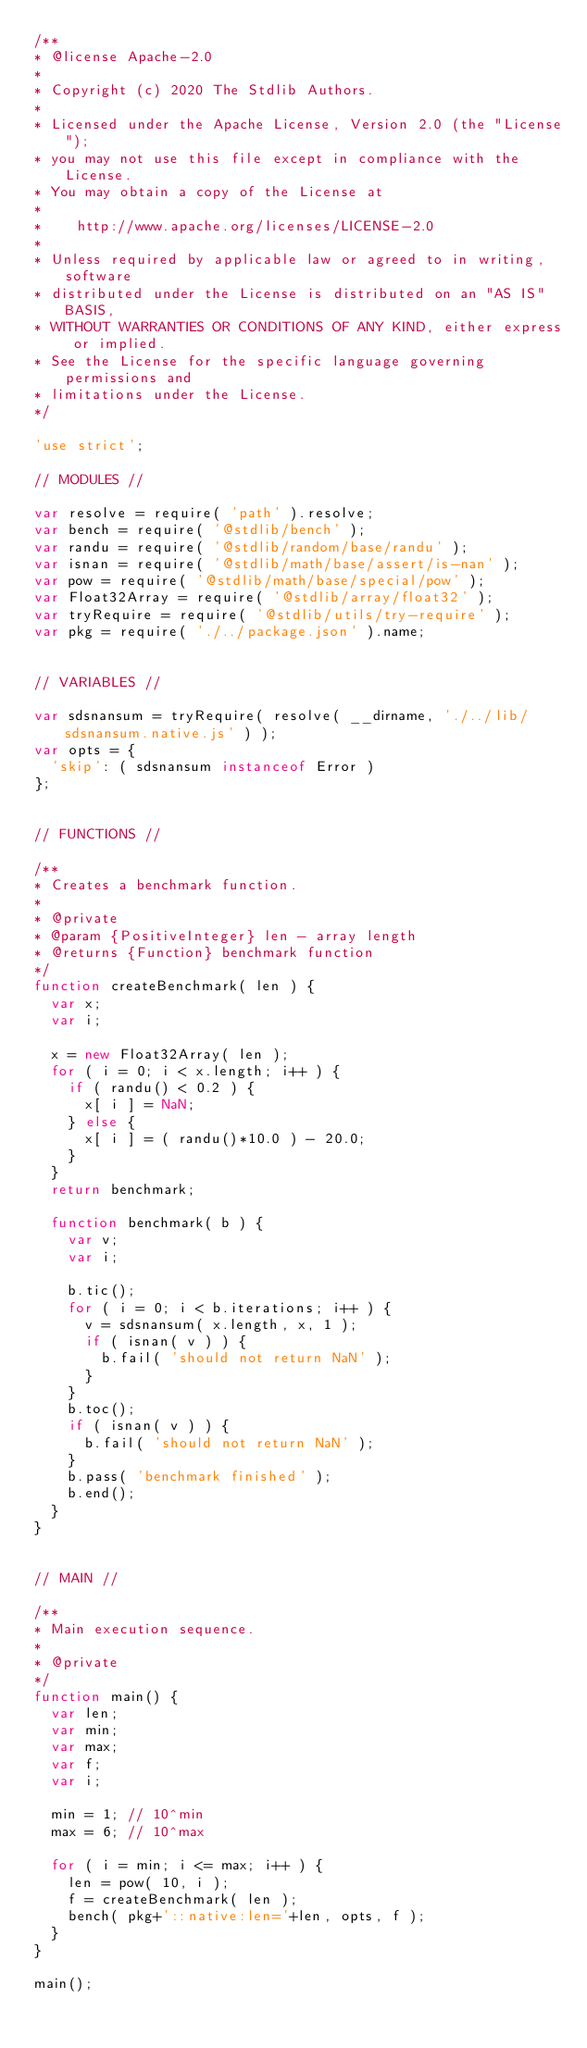Convert code to text. <code><loc_0><loc_0><loc_500><loc_500><_JavaScript_>/**
* @license Apache-2.0
*
* Copyright (c) 2020 The Stdlib Authors.
*
* Licensed under the Apache License, Version 2.0 (the "License");
* you may not use this file except in compliance with the License.
* You may obtain a copy of the License at
*
*    http://www.apache.org/licenses/LICENSE-2.0
*
* Unless required by applicable law or agreed to in writing, software
* distributed under the License is distributed on an "AS IS" BASIS,
* WITHOUT WARRANTIES OR CONDITIONS OF ANY KIND, either express or implied.
* See the License for the specific language governing permissions and
* limitations under the License.
*/

'use strict';

// MODULES //

var resolve = require( 'path' ).resolve;
var bench = require( '@stdlib/bench' );
var randu = require( '@stdlib/random/base/randu' );
var isnan = require( '@stdlib/math/base/assert/is-nan' );
var pow = require( '@stdlib/math/base/special/pow' );
var Float32Array = require( '@stdlib/array/float32' );
var tryRequire = require( '@stdlib/utils/try-require' );
var pkg = require( './../package.json' ).name;


// VARIABLES //

var sdsnansum = tryRequire( resolve( __dirname, './../lib/sdsnansum.native.js' ) );
var opts = {
	'skip': ( sdsnansum instanceof Error )
};


// FUNCTIONS //

/**
* Creates a benchmark function.
*
* @private
* @param {PositiveInteger} len - array length
* @returns {Function} benchmark function
*/
function createBenchmark( len ) {
	var x;
	var i;

	x = new Float32Array( len );
	for ( i = 0; i < x.length; i++ ) {
		if ( randu() < 0.2 ) {
			x[ i ] = NaN;
		} else {
			x[ i ] = ( randu()*10.0 ) - 20.0;
		}
	}
	return benchmark;

	function benchmark( b ) {
		var v;
		var i;

		b.tic();
		for ( i = 0; i < b.iterations; i++ ) {
			v = sdsnansum( x.length, x, 1 );
			if ( isnan( v ) ) {
				b.fail( 'should not return NaN' );
			}
		}
		b.toc();
		if ( isnan( v ) ) {
			b.fail( 'should not return NaN' );
		}
		b.pass( 'benchmark finished' );
		b.end();
	}
}


// MAIN //

/**
* Main execution sequence.
*
* @private
*/
function main() {
	var len;
	var min;
	var max;
	var f;
	var i;

	min = 1; // 10^min
	max = 6; // 10^max

	for ( i = min; i <= max; i++ ) {
		len = pow( 10, i );
		f = createBenchmark( len );
		bench( pkg+'::native:len='+len, opts, f );
	}
}

main();
</code> 